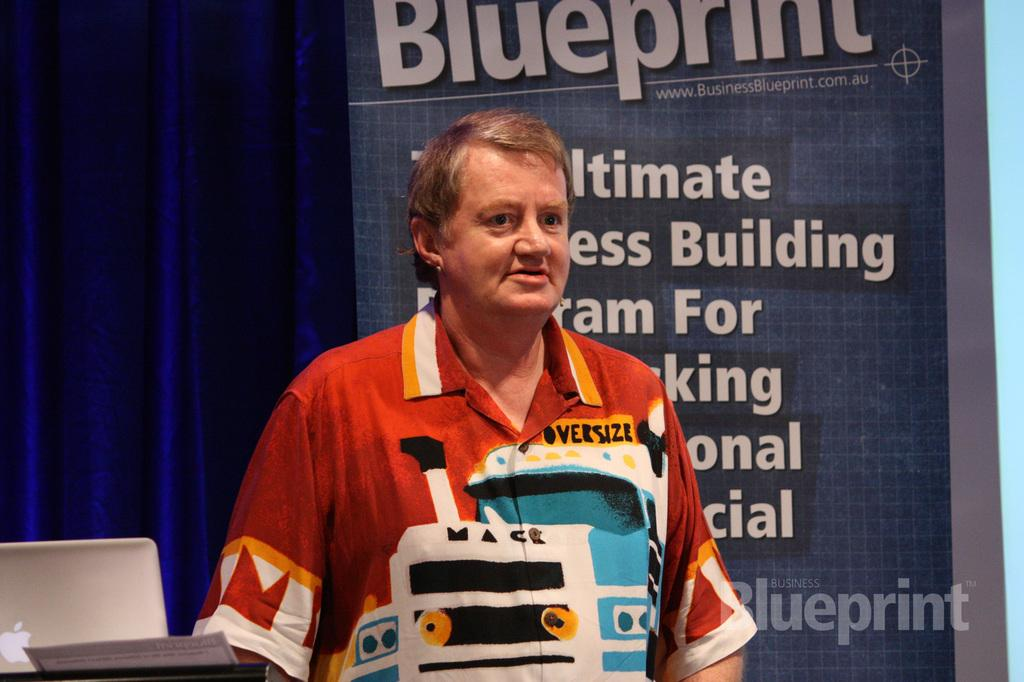<image>
Summarize the visual content of the image. Man that is sponsoring for Blueprint he is wearing a shirt that says oversize. 